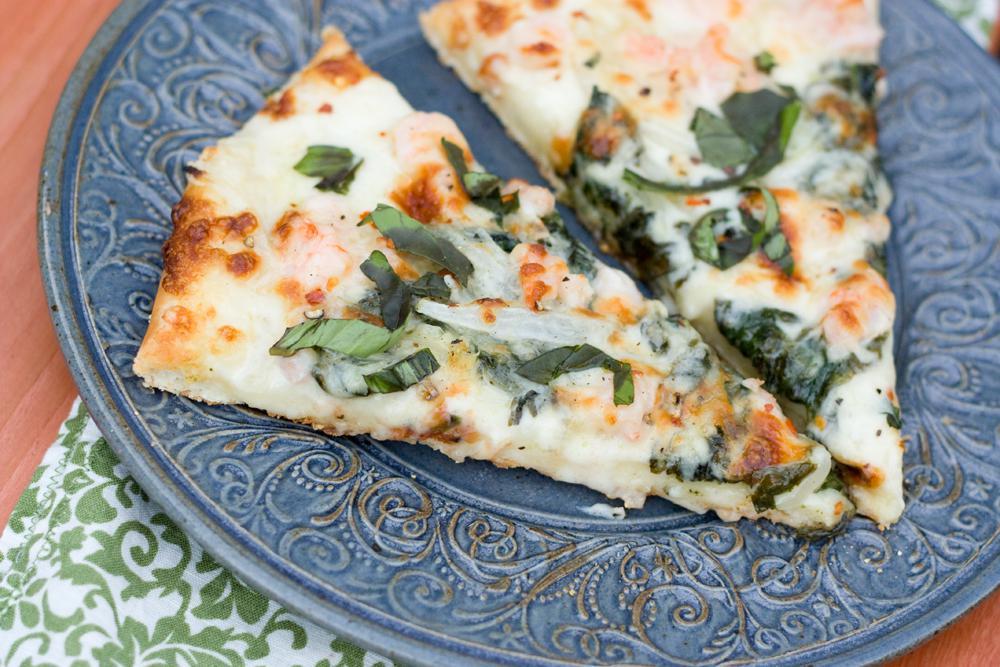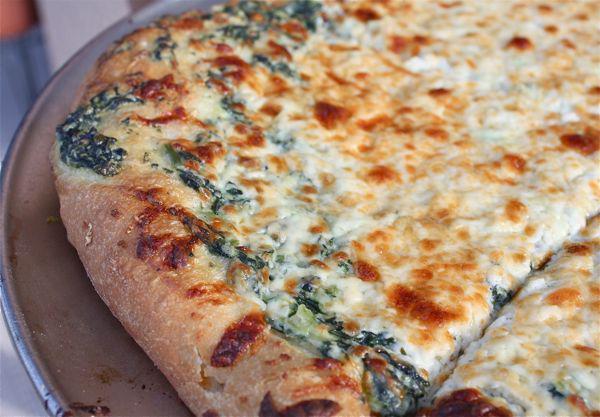The first image is the image on the left, the second image is the image on the right. For the images shown, is this caption "A pizza has sliced tomatoes." true? Answer yes or no. No. The first image is the image on the left, the second image is the image on the right. Given the left and right images, does the statement "One image shows a baked, brown-crusted pizza with no slices removed, and the other image shows less than an entire pizza." hold true? Answer yes or no. Yes. 